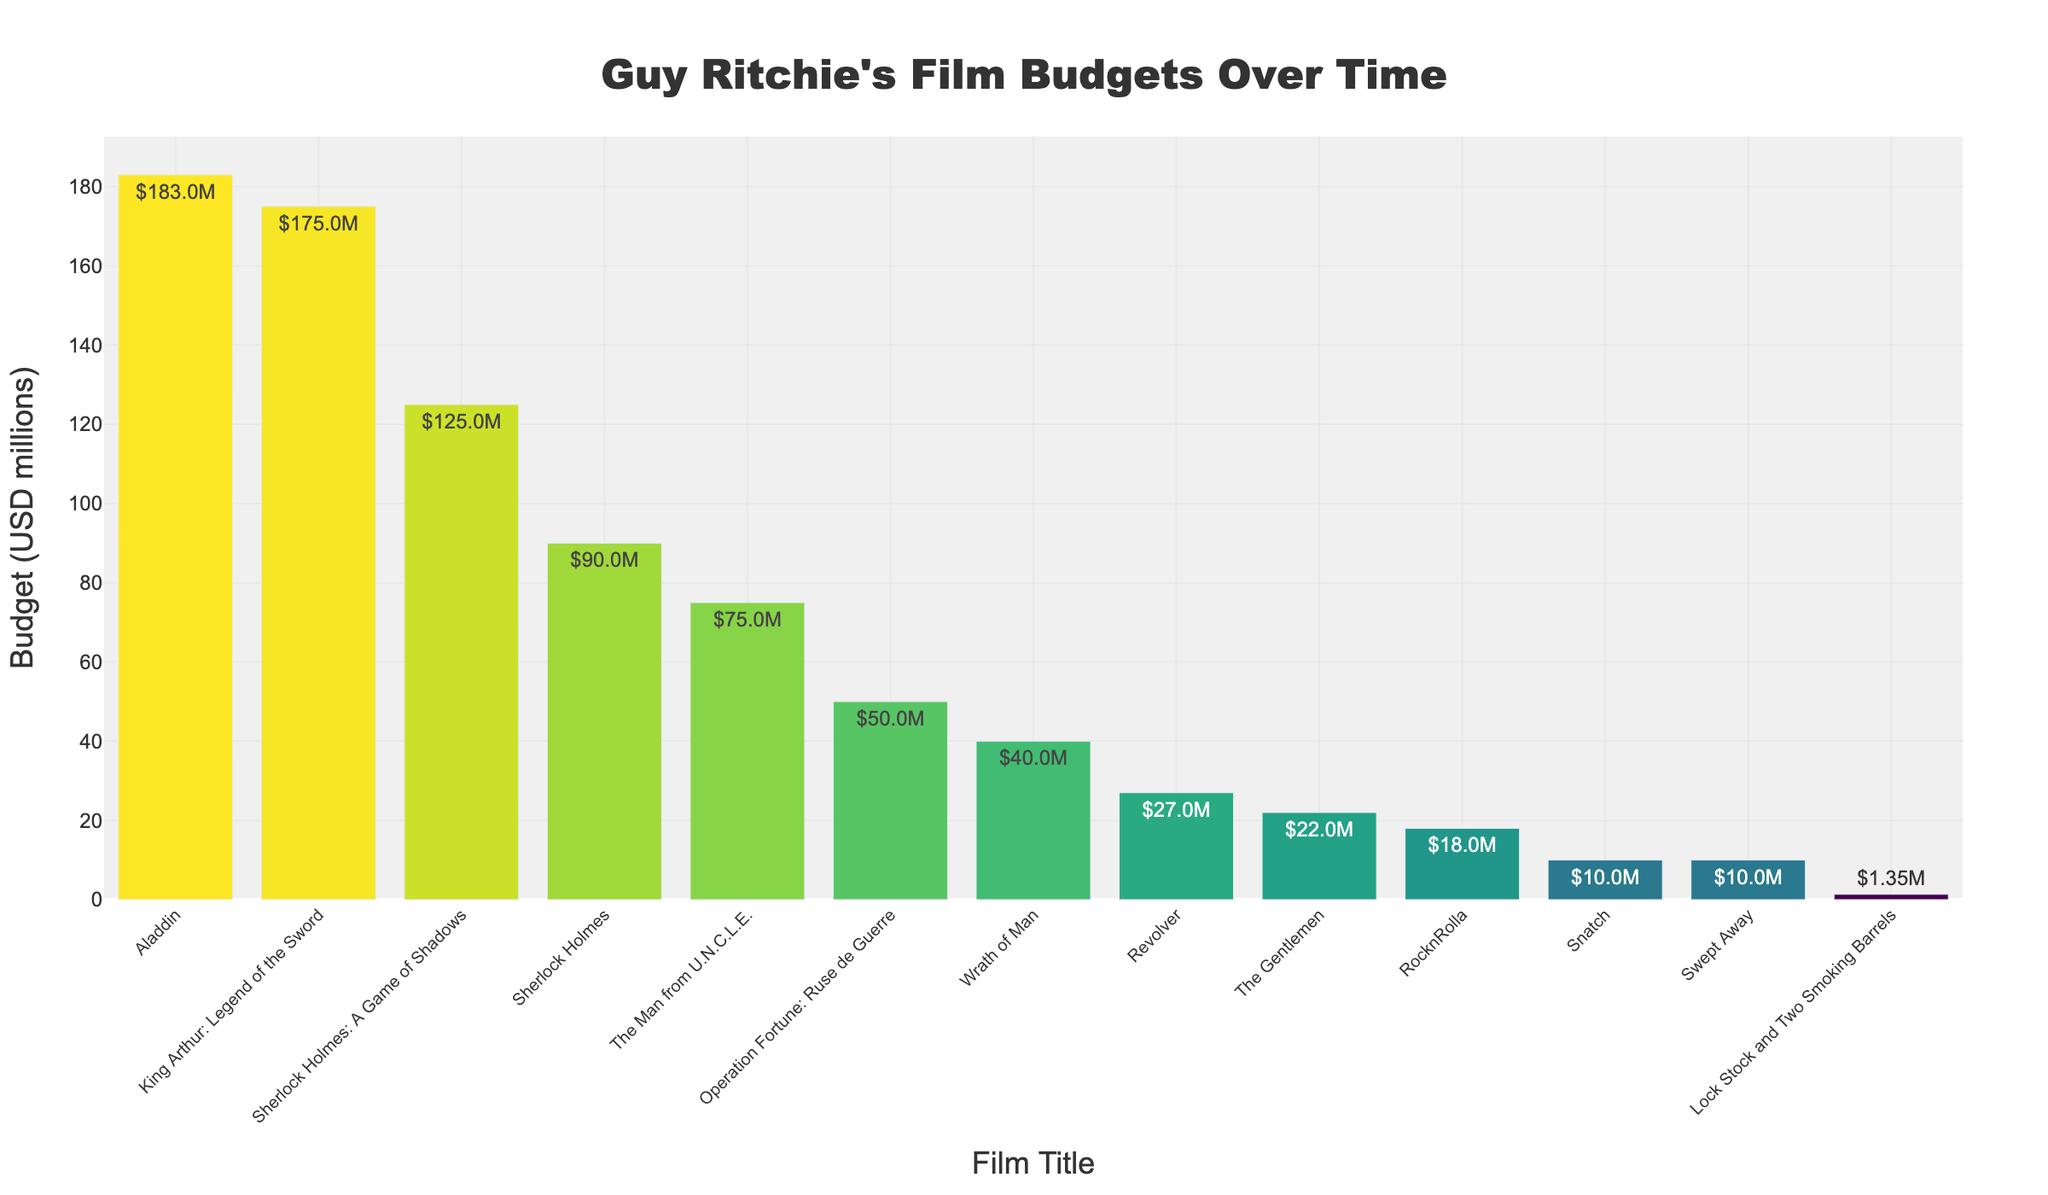Which film had the highest budget? By inspecting the bar chart, the tallest bar represents the film with the highest budget. Aladdin has the tallest bar.
Answer: Aladdin Which two films have the closest budget sizes? By comparing the lengths of the bars, Swept Away and Snatch both have bars of similar height, indicating their budgets are closest.
Answer: Swept Away and Snatch What's the total budget for both Sherlock Holmes films? The budget for Sherlock Holmes is $90M and for Sherlock Holmes: A Game of Shadows is $125M. Summing these, 90 + 125 = 215.
Answer: $215M How does the budget of The Gentlemen compare to Wrath of Man? The bar for Wrath of Man is higher than The Gentlemen, indicating a larger budget.
Answer: Wrath of Man has a larger budget Which film's budget is larger, King Arthur: Legend of the Sword or The Man from U.N.C.L.E.? The bar for King Arthur: Legend of the Sword is taller than that for The Man from U.N.C.L.E., indicating a larger budget.
Answer: King Arthur: Legend of the Sword What is the average budget of the films with budgets over $100M? The films with budgets over $100M are Sherlock Holmes: A Game of Shadows ($125M), King Arthur: Legend of the Sword ($175M), and Aladdin ($183M). Calculating the average: (125 + 175 + 183) / 3 = 161.
Answer: $161M How many films have budgets under $50M? Counting the bars that are shorter than those representing a $50M budget, there are eight films: Lock Stock and Two Smoking Barrels, Snatch, Swept Away, Revolver, RocknRolla, The Gentlemen, Wrath of Man, and The Man from U.N.C.L.E.
Answer: Eight films What is the difference in budget between Aladdin and Lock Stock and Two Smoking Barrels? Subtracting the smaller budget from the larger one: 183 - 1.35 = 181.65.
Answer: $181.65M Which film had a significantly lower budget than the majority of Guy Ritchie's later films? The shortest bar represents Lock Stock and Two Smoking Barrels, with a budget considerably lower than his later films.
Answer: Lock Stock and Two Smoking Barrels What is the combined budget of the three films with the lowest budgets? The three films with the lowest budgets are Lock Stock and Two Smoking Barrels ($1.35M), Snatch ($10M), and Swept Away ($10M). Summing these: 1.35 + 10 + 10 = 21.35.
Answer: $21.35M 